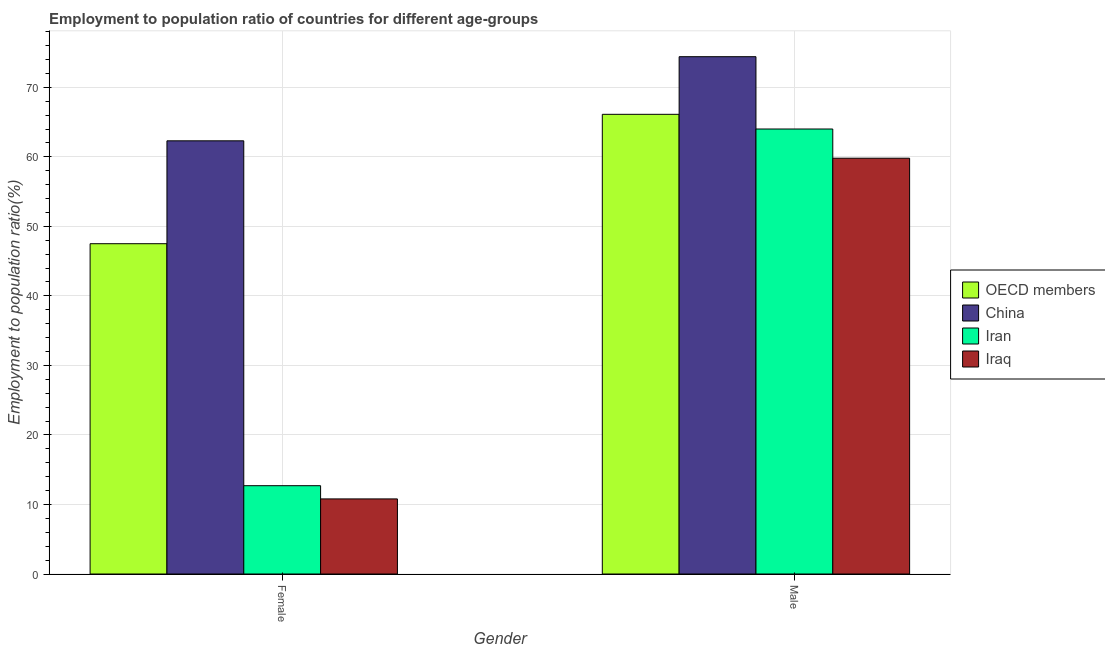How many different coloured bars are there?
Ensure brevity in your answer.  4. Are the number of bars per tick equal to the number of legend labels?
Make the answer very short. Yes. Are the number of bars on each tick of the X-axis equal?
Offer a terse response. Yes. How many bars are there on the 2nd tick from the left?
Your answer should be very brief. 4. How many bars are there on the 1st tick from the right?
Your answer should be very brief. 4. What is the label of the 2nd group of bars from the left?
Give a very brief answer. Male. What is the employment to population ratio(male) in Iraq?
Ensure brevity in your answer.  59.8. Across all countries, what is the maximum employment to population ratio(female)?
Provide a short and direct response. 62.3. Across all countries, what is the minimum employment to population ratio(female)?
Keep it short and to the point. 10.8. In which country was the employment to population ratio(female) maximum?
Provide a short and direct response. China. In which country was the employment to population ratio(female) minimum?
Give a very brief answer. Iraq. What is the total employment to population ratio(male) in the graph?
Your answer should be compact. 264.31. What is the difference between the employment to population ratio(male) in OECD members and that in China?
Give a very brief answer. -8.29. What is the difference between the employment to population ratio(female) in Iran and the employment to population ratio(male) in China?
Your response must be concise. -61.7. What is the average employment to population ratio(male) per country?
Your response must be concise. 66.08. What is the difference between the employment to population ratio(male) and employment to population ratio(female) in Iran?
Keep it short and to the point. 51.3. What is the ratio of the employment to population ratio(female) in Iran to that in Iraq?
Make the answer very short. 1.18. In how many countries, is the employment to population ratio(female) greater than the average employment to population ratio(female) taken over all countries?
Ensure brevity in your answer.  2. What does the 3rd bar from the left in Male represents?
Your response must be concise. Iran. Are the values on the major ticks of Y-axis written in scientific E-notation?
Make the answer very short. No. Does the graph contain any zero values?
Make the answer very short. No. How many legend labels are there?
Ensure brevity in your answer.  4. What is the title of the graph?
Keep it short and to the point. Employment to population ratio of countries for different age-groups. What is the label or title of the X-axis?
Offer a very short reply. Gender. What is the label or title of the Y-axis?
Your answer should be very brief. Employment to population ratio(%). What is the Employment to population ratio(%) in OECD members in Female?
Provide a succinct answer. 47.5. What is the Employment to population ratio(%) in China in Female?
Your answer should be compact. 62.3. What is the Employment to population ratio(%) in Iran in Female?
Provide a short and direct response. 12.7. What is the Employment to population ratio(%) of Iraq in Female?
Your response must be concise. 10.8. What is the Employment to population ratio(%) of OECD members in Male?
Your response must be concise. 66.11. What is the Employment to population ratio(%) of China in Male?
Provide a succinct answer. 74.4. What is the Employment to population ratio(%) of Iraq in Male?
Ensure brevity in your answer.  59.8. Across all Gender, what is the maximum Employment to population ratio(%) of OECD members?
Make the answer very short. 66.11. Across all Gender, what is the maximum Employment to population ratio(%) of China?
Make the answer very short. 74.4. Across all Gender, what is the maximum Employment to population ratio(%) of Iraq?
Your response must be concise. 59.8. Across all Gender, what is the minimum Employment to population ratio(%) of OECD members?
Keep it short and to the point. 47.5. Across all Gender, what is the minimum Employment to population ratio(%) of China?
Give a very brief answer. 62.3. Across all Gender, what is the minimum Employment to population ratio(%) in Iran?
Make the answer very short. 12.7. Across all Gender, what is the minimum Employment to population ratio(%) of Iraq?
Your response must be concise. 10.8. What is the total Employment to population ratio(%) of OECD members in the graph?
Keep it short and to the point. 113.61. What is the total Employment to population ratio(%) of China in the graph?
Offer a terse response. 136.7. What is the total Employment to population ratio(%) of Iran in the graph?
Provide a succinct answer. 76.7. What is the total Employment to population ratio(%) of Iraq in the graph?
Ensure brevity in your answer.  70.6. What is the difference between the Employment to population ratio(%) of OECD members in Female and that in Male?
Your answer should be very brief. -18.61. What is the difference between the Employment to population ratio(%) in China in Female and that in Male?
Your answer should be compact. -12.1. What is the difference between the Employment to population ratio(%) of Iran in Female and that in Male?
Your answer should be compact. -51.3. What is the difference between the Employment to population ratio(%) of Iraq in Female and that in Male?
Make the answer very short. -49. What is the difference between the Employment to population ratio(%) in OECD members in Female and the Employment to population ratio(%) in China in Male?
Ensure brevity in your answer.  -26.9. What is the difference between the Employment to population ratio(%) in OECD members in Female and the Employment to population ratio(%) in Iran in Male?
Your answer should be compact. -16.5. What is the difference between the Employment to population ratio(%) in OECD members in Female and the Employment to population ratio(%) in Iraq in Male?
Your answer should be very brief. -12.3. What is the difference between the Employment to population ratio(%) of China in Female and the Employment to population ratio(%) of Iran in Male?
Give a very brief answer. -1.7. What is the difference between the Employment to population ratio(%) of China in Female and the Employment to population ratio(%) of Iraq in Male?
Your response must be concise. 2.5. What is the difference between the Employment to population ratio(%) of Iran in Female and the Employment to population ratio(%) of Iraq in Male?
Offer a terse response. -47.1. What is the average Employment to population ratio(%) of OECD members per Gender?
Offer a terse response. 56.81. What is the average Employment to population ratio(%) in China per Gender?
Provide a succinct answer. 68.35. What is the average Employment to population ratio(%) in Iran per Gender?
Provide a succinct answer. 38.35. What is the average Employment to population ratio(%) of Iraq per Gender?
Your answer should be very brief. 35.3. What is the difference between the Employment to population ratio(%) of OECD members and Employment to population ratio(%) of China in Female?
Provide a short and direct response. -14.8. What is the difference between the Employment to population ratio(%) of OECD members and Employment to population ratio(%) of Iran in Female?
Offer a terse response. 34.8. What is the difference between the Employment to population ratio(%) of OECD members and Employment to population ratio(%) of Iraq in Female?
Offer a terse response. 36.7. What is the difference between the Employment to population ratio(%) in China and Employment to population ratio(%) in Iran in Female?
Your answer should be very brief. 49.6. What is the difference between the Employment to population ratio(%) of China and Employment to population ratio(%) of Iraq in Female?
Provide a short and direct response. 51.5. What is the difference between the Employment to population ratio(%) in OECD members and Employment to population ratio(%) in China in Male?
Give a very brief answer. -8.29. What is the difference between the Employment to population ratio(%) of OECD members and Employment to population ratio(%) of Iran in Male?
Give a very brief answer. 2.11. What is the difference between the Employment to population ratio(%) in OECD members and Employment to population ratio(%) in Iraq in Male?
Your answer should be very brief. 6.31. What is the difference between the Employment to population ratio(%) of China and Employment to population ratio(%) of Iraq in Male?
Your answer should be very brief. 14.6. What is the difference between the Employment to population ratio(%) of Iran and Employment to population ratio(%) of Iraq in Male?
Keep it short and to the point. 4.2. What is the ratio of the Employment to population ratio(%) in OECD members in Female to that in Male?
Your answer should be very brief. 0.72. What is the ratio of the Employment to population ratio(%) in China in Female to that in Male?
Ensure brevity in your answer.  0.84. What is the ratio of the Employment to population ratio(%) of Iran in Female to that in Male?
Offer a very short reply. 0.2. What is the ratio of the Employment to population ratio(%) in Iraq in Female to that in Male?
Give a very brief answer. 0.18. What is the difference between the highest and the second highest Employment to population ratio(%) of OECD members?
Your answer should be compact. 18.61. What is the difference between the highest and the second highest Employment to population ratio(%) in Iran?
Provide a short and direct response. 51.3. What is the difference between the highest and the lowest Employment to population ratio(%) of OECD members?
Provide a succinct answer. 18.61. What is the difference between the highest and the lowest Employment to population ratio(%) in China?
Your answer should be very brief. 12.1. What is the difference between the highest and the lowest Employment to population ratio(%) in Iran?
Provide a succinct answer. 51.3. What is the difference between the highest and the lowest Employment to population ratio(%) in Iraq?
Your response must be concise. 49. 